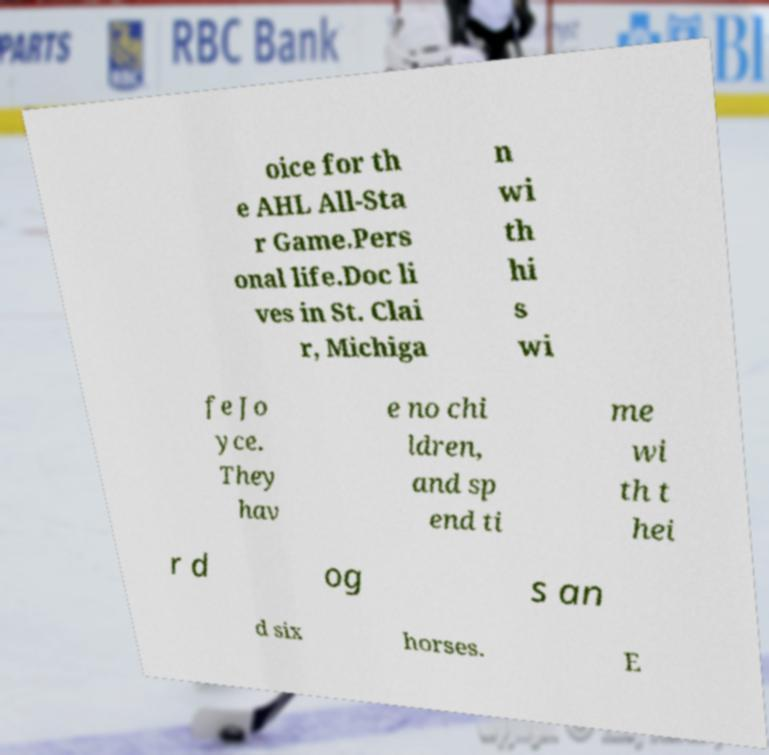Please read and relay the text visible in this image. What does it say? oice for th e AHL All-Sta r Game.Pers onal life.Doc li ves in St. Clai r, Michiga n wi th hi s wi fe Jo yce. They hav e no chi ldren, and sp end ti me wi th t hei r d og s an d six horses. E 